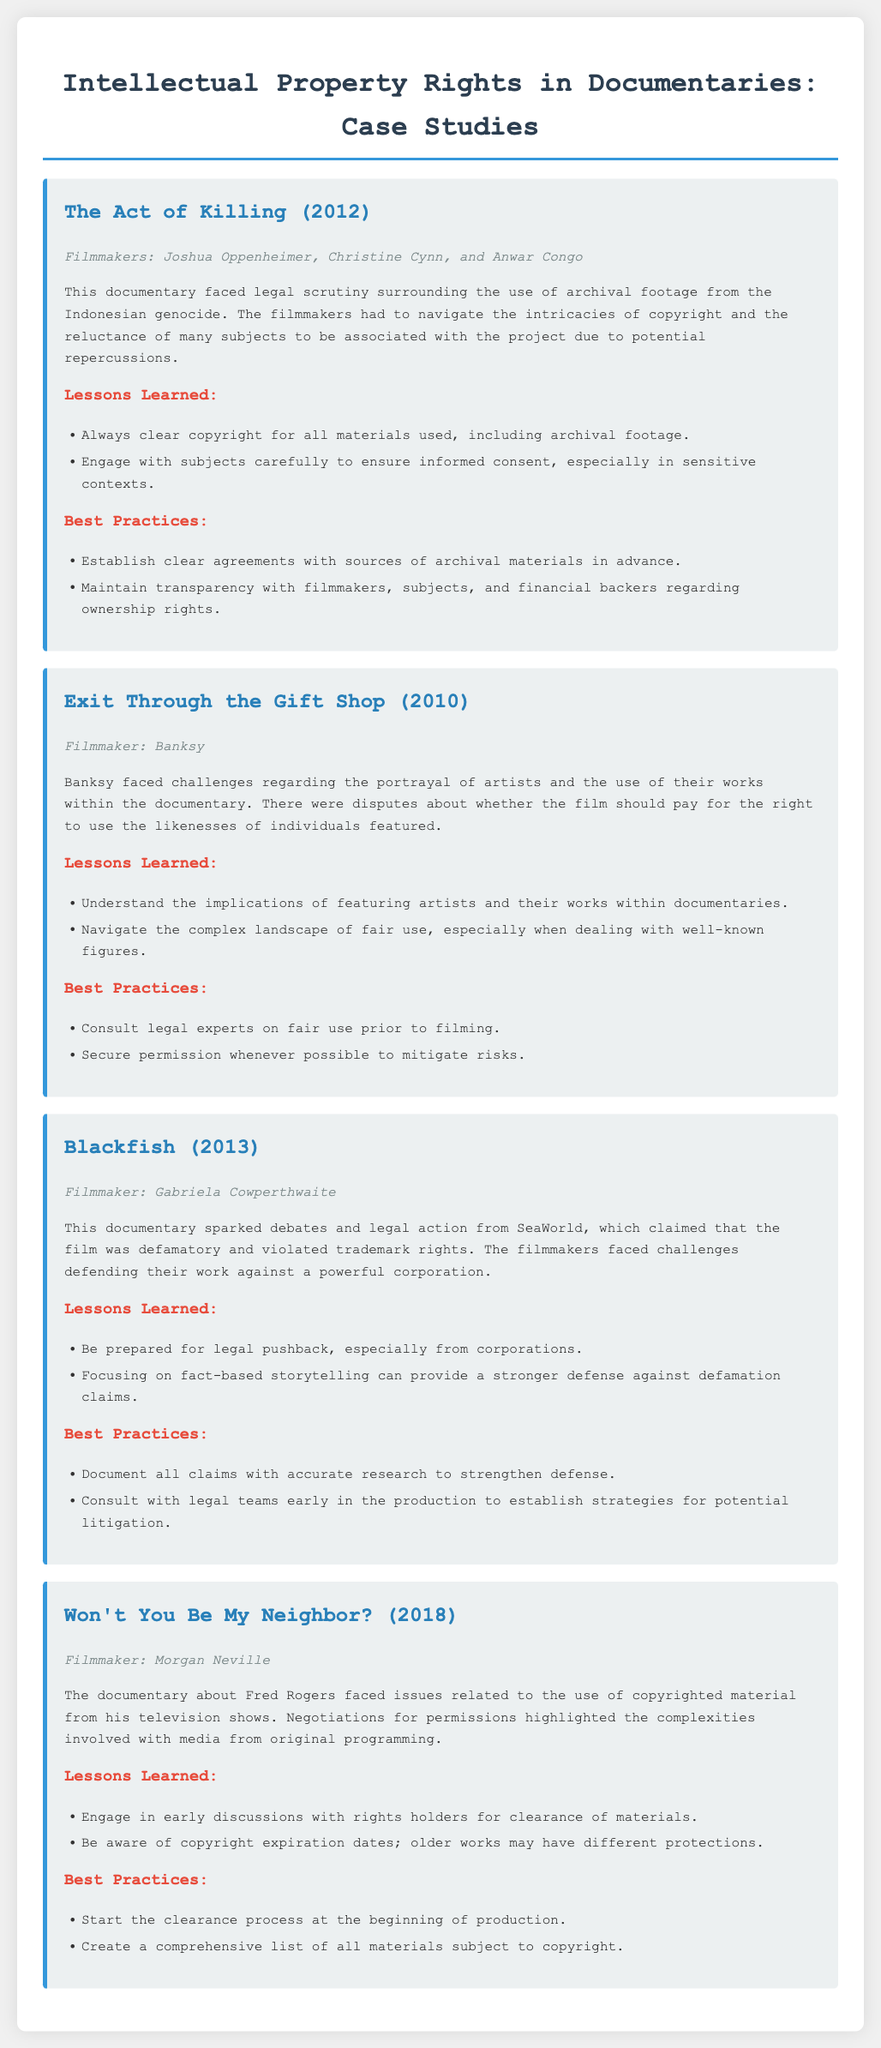What is the title of the documentary released in 2012? The title is the name of the documentary listed in the document, which is "The Act of Killing."
Answer: The Act of Killing Who directed "Exit Through the Gift Shop"? The name of the filmmaker associated with this documentary is provided, which is Banksy.
Answer: Banksy What year was "Blackfish" released? The release year of this documentary is mentioned directly in the document, which is 2013.
Answer: 2013 What was a lesson learned from "Won't You Be My Neighbor?" The document states the lesson learned was to engage in early discussions with rights holders for clearance of materials.
Answer: Engage in early discussions with rights holders for clearance of materials What sparked debates and legal action from SeaWorld? The document mentions "Blackfish" as the documentary that sparked these issues.
Answer: Blackfish Which documentary faced issues regarding the portrayal of artists? The document explicitly states that "Exit Through the Gift Shop" faced these challenges.
Answer: Exit Through the Gift Shop What is one best practice mentioned for "The Act of Killing"? The document lists establishing clear agreements with sources of archival materials in advance as a best practice.
Answer: Establish clear agreements with sources of archival materials in advance What type of footage did "The Act of Killing" use? The document indicates that it used archival footage related to the Indonesian genocide.
Answer: Archival footage What was a challenge faced by "Won't You Be My Neighbor?" The document describes challenges related to the use of copyrighted material from Fred Rogers' television shows.
Answer: Use of copyrighted material from Fred Rogers' television shows 